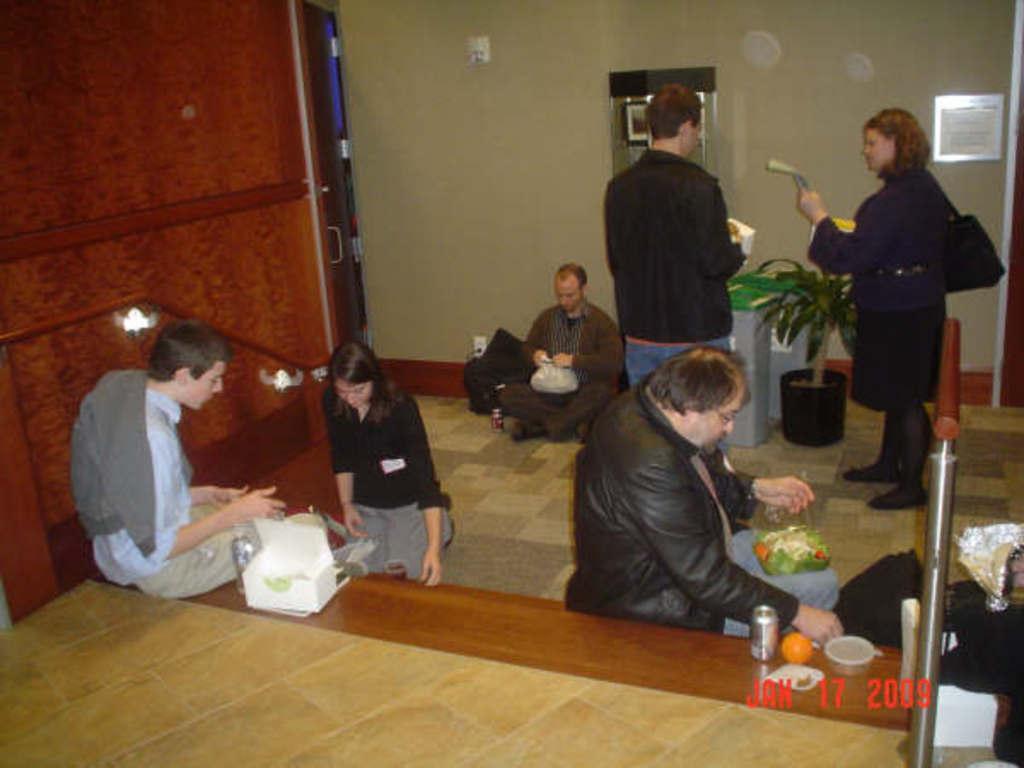Please provide a concise description of this image. In this image there are three people seated on stairs and having food, in front of them there are two other people standing, holding some objects in their hand. 